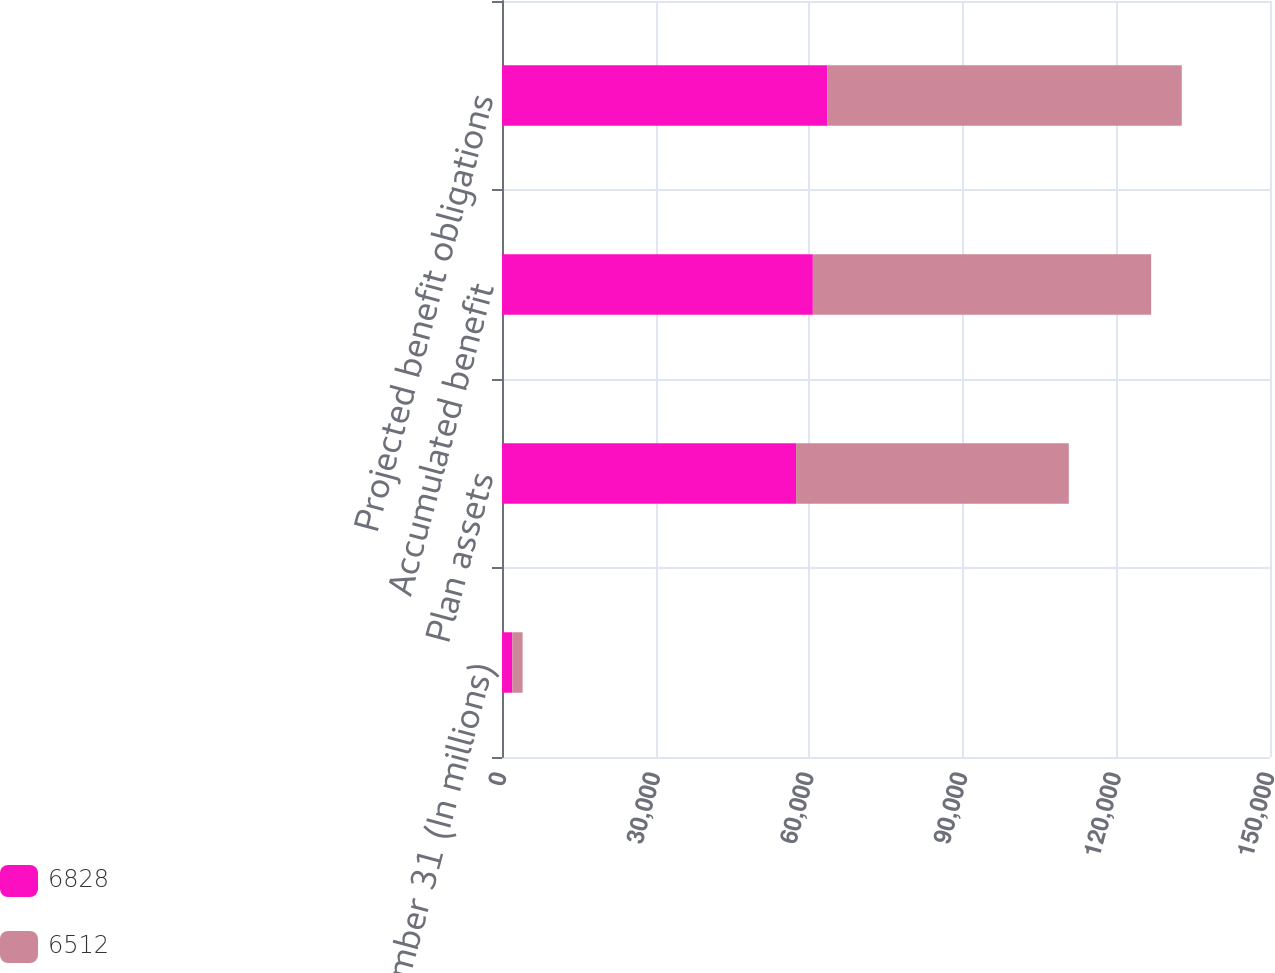<chart> <loc_0><loc_0><loc_500><loc_500><stacked_bar_chart><ecel><fcel>December 31 (In millions)<fcel>Plan assets<fcel>Accumulated benefit<fcel>Projected benefit obligations<nl><fcel>6828<fcel>2013<fcel>57430<fcel>60715<fcel>63532<nl><fcel>6512<fcel>2012<fcel>53276<fcel>66069<fcel>69234<nl></chart> 